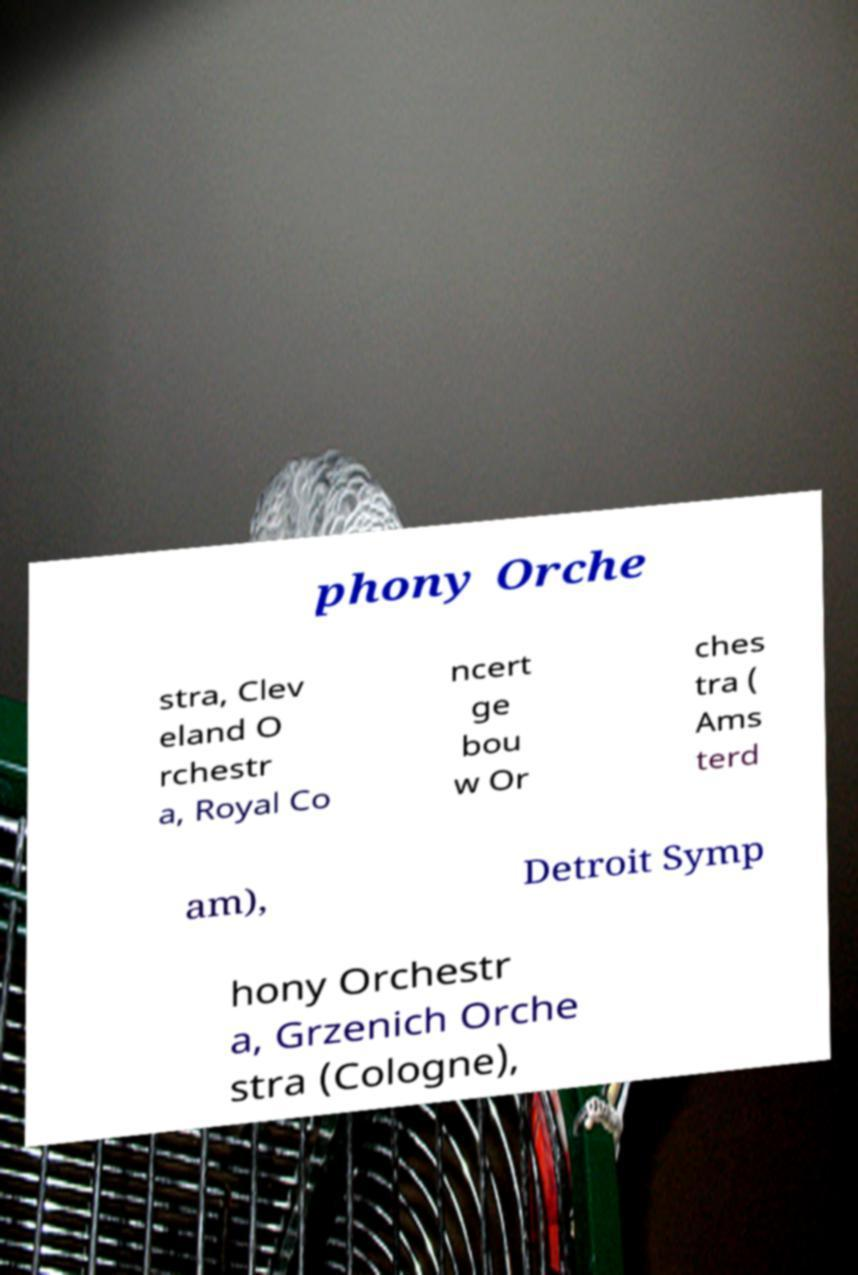Can you read and provide the text displayed in the image?This photo seems to have some interesting text. Can you extract and type it out for me? phony Orche stra, Clev eland O rchestr a, Royal Co ncert ge bou w Or ches tra ( Ams terd am), Detroit Symp hony Orchestr a, Grzenich Orche stra (Cologne), 